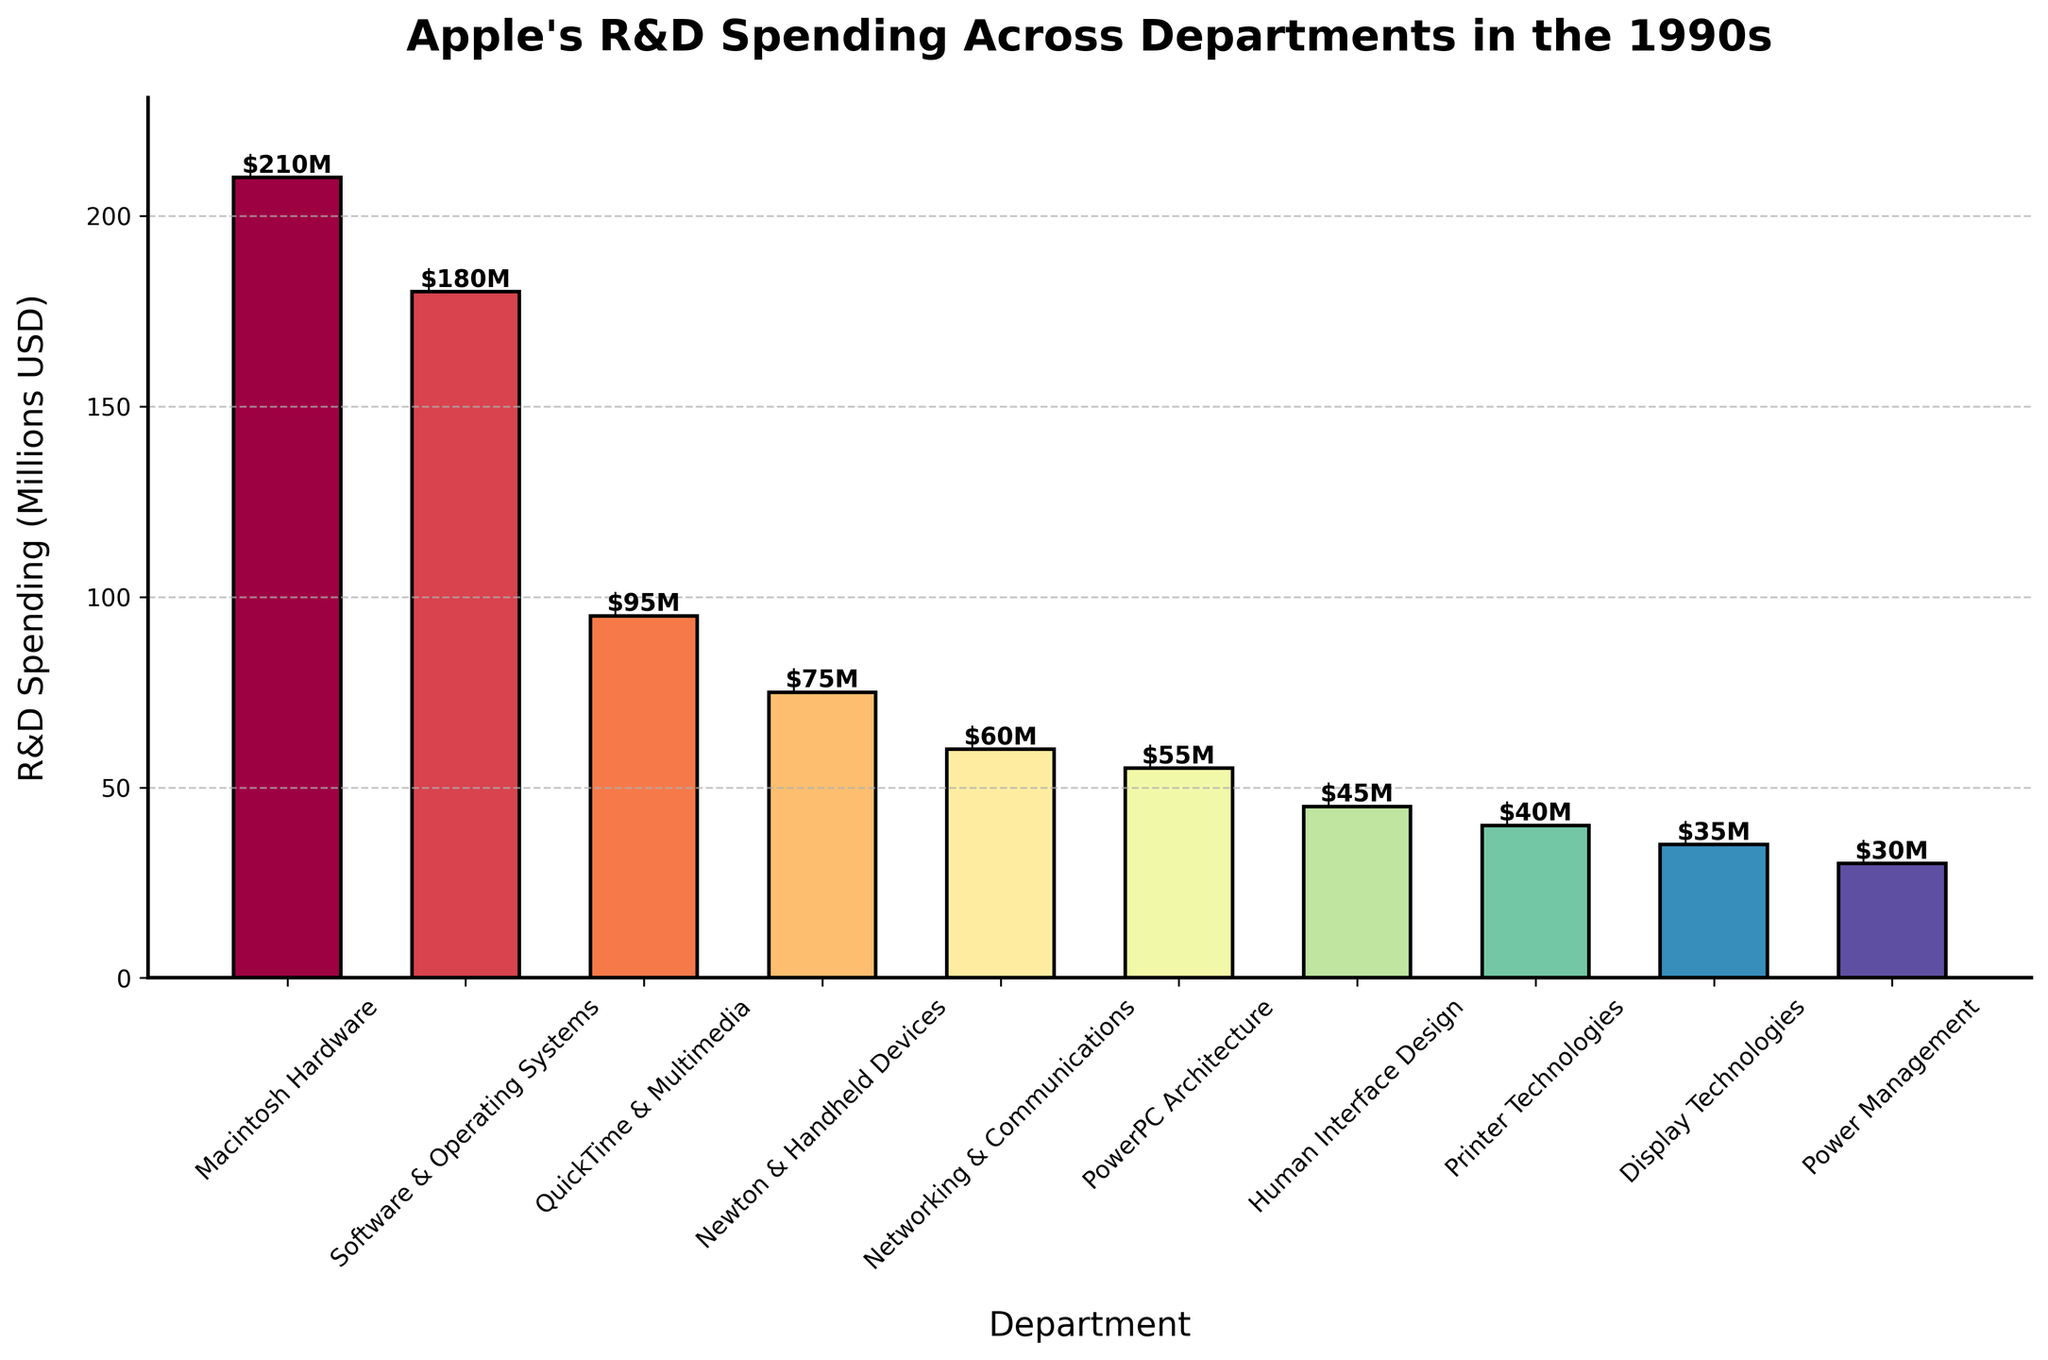Which department received the highest R&D spending? We can identify the tallest bar on the chart and find that it corresponds to "Macintosh Hardware". The label on the bar confirms it shows $210M, which is the highest spending among all departments.
Answer: Macintosh Hardware Which department received the lowest R&D spending? By identifying the shortest bar on the chart, we see that "Power Management" received the lowest spending. The label on this bar confirms it to be $30M.
Answer: Power Management How much more did Apple spend on Macintosh Hardware compared to Display Technologies? We need to subtract the R&D spending for Display Technologies from that of Macintosh Hardware. So, $210M - $35M = $175M.
Answer: $175M What is the total R&D spending for Newton & Handheld Devices and Printer Technologies combined? Adding the R&D spending for Newton & Handheld Devices ($75M) and Printer Technologies ($40M) gives: $75M + $40M = $115M.
Answer: $115M Which departments have R&D spending amounts greater than $100M? The bars with labels above $100M are for "Macintosh Hardware ($210M)" and "Software & Operating Systems ($180M)". These are the only departments with spending over $100M.
Answer: Macintosh Hardware, Software & Operating Systems What is the average R&D spending across all departments? First, sum up all the R&D spending: 210 + 180 + 95 + 75 + 60 + 55 + 45 + 40 + 35 + 30 = $825M. Then, divide this sum by the number of departments (10): $825M / 10 = $82.5M.
Answer: $82.5M How does the spending on QuickTime & Multimedia compare to Software & Operating Systems? Comparing the heights and labels of the bars for these departments: QuickTime & Multimedia has $95M, whereas Software & Operating Systems has $180M. Thus, Software & Operating Systems had higher spending.
Answer: Software & Operating Systems has higher spending What is the combined spending of the three departments with the lowest R&D spending? The three departments with the lowest spending are Display Technologies ($35M), Power Management ($30M), and Printer Technologies ($40M). Their combined spending is $35M + $30M + $40M = $105M.
Answer: $105M What percentage of total R&D spending is attributed to Networking & Communications? First, we find the total R&D spending, which is $825M. The R&D spending for Networking & Communications is $60M. To find the percentage: ($60M / $825M) * 100% ≈ 7.27%.
Answer: ~7.27% Which department's bar is at a midpoint of R&D spending between the highest and lowest spender? The highest and lowest R&D spenders are Macintosh Hardware ($210M) and Power Management ($30M), respectively. The midpoint is ($210M + $30M) / 2 = $120M. Among the departments, QuickTime & Multimedia ($95M) is closest to this midpoint but does not exactly match it.
Answer: QuickTime & Multimedia (closest) 